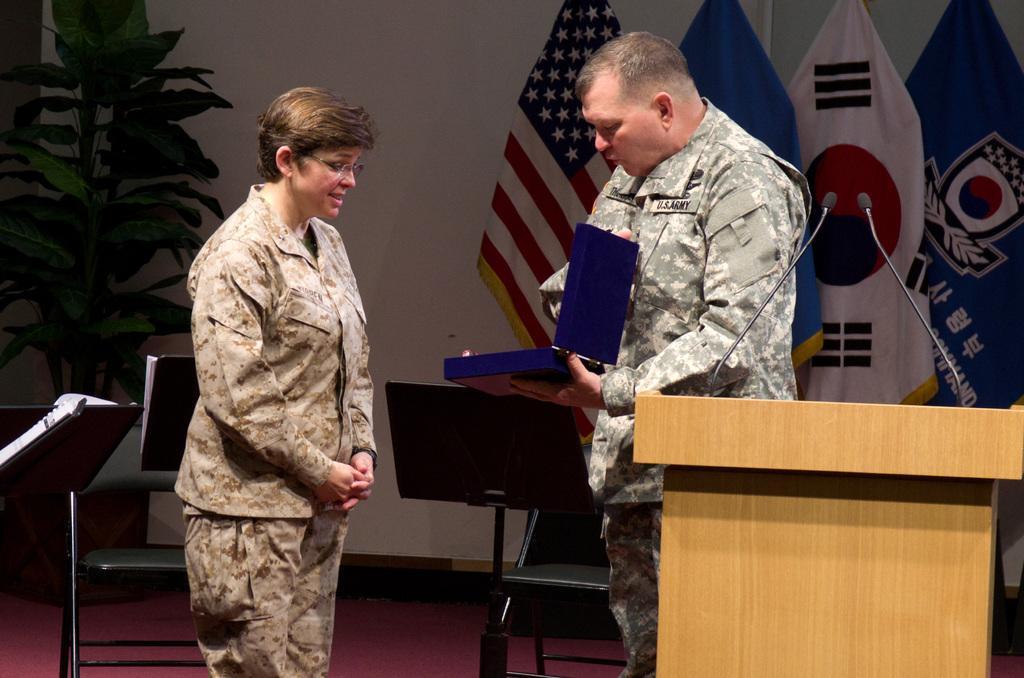How would you summarize this image in a sentence or two? In this picture I can see two persons standing, there is a person holding an object, there are mikes on the podium, there are chairs and musical book stands, and in the background there are flags and a house plant. 